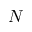<formula> <loc_0><loc_0><loc_500><loc_500>N</formula> 